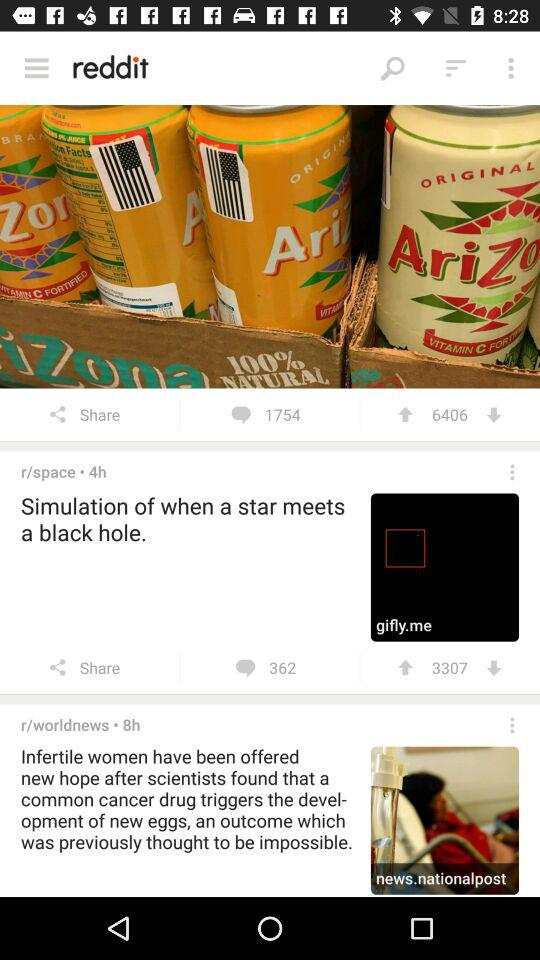When did "r/worldnews" post? "r/worldnews" posted the post 8 hours ago. 